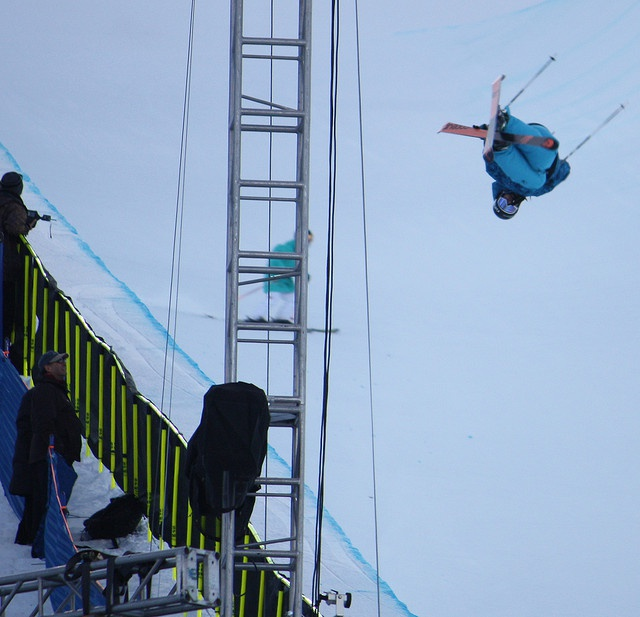Describe the objects in this image and their specific colors. I can see backpack in darkgray, black, navy, gray, and lightblue tones, people in darkgray, teal, navy, black, and blue tones, people in darkgray, black, and gray tones, people in darkgray, black, navy, and lightblue tones, and people in darkgray, lightblue, teal, blue, and gray tones in this image. 